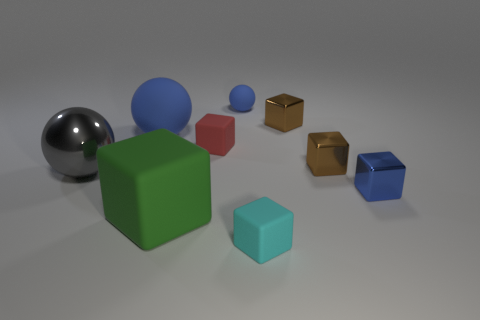There is a small thing that is the same color as the small rubber sphere; what is its shape?
Ensure brevity in your answer.  Cube. Is there a purple object made of the same material as the large green thing?
Offer a terse response. No. The tiny blue matte object is what shape?
Provide a succinct answer. Sphere. How many metal things are there?
Ensure brevity in your answer.  4. What is the color of the cube that is behind the blue rubber ball to the left of the big cube?
Your answer should be compact. Brown. What is the color of the cube that is the same size as the gray sphere?
Offer a terse response. Green. Are there any metallic blocks that have the same color as the tiny matte ball?
Provide a succinct answer. Yes. Are there any cyan things?
Your answer should be very brief. Yes. The tiny blue thing that is left of the tiny cyan matte block has what shape?
Give a very brief answer. Sphere. What number of matte objects are in front of the tiny blue metal block and behind the red matte thing?
Ensure brevity in your answer.  0. 